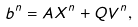<formula> <loc_0><loc_0><loc_500><loc_500>b ^ { n } = A X ^ { n } + Q V ^ { n } ,</formula> 